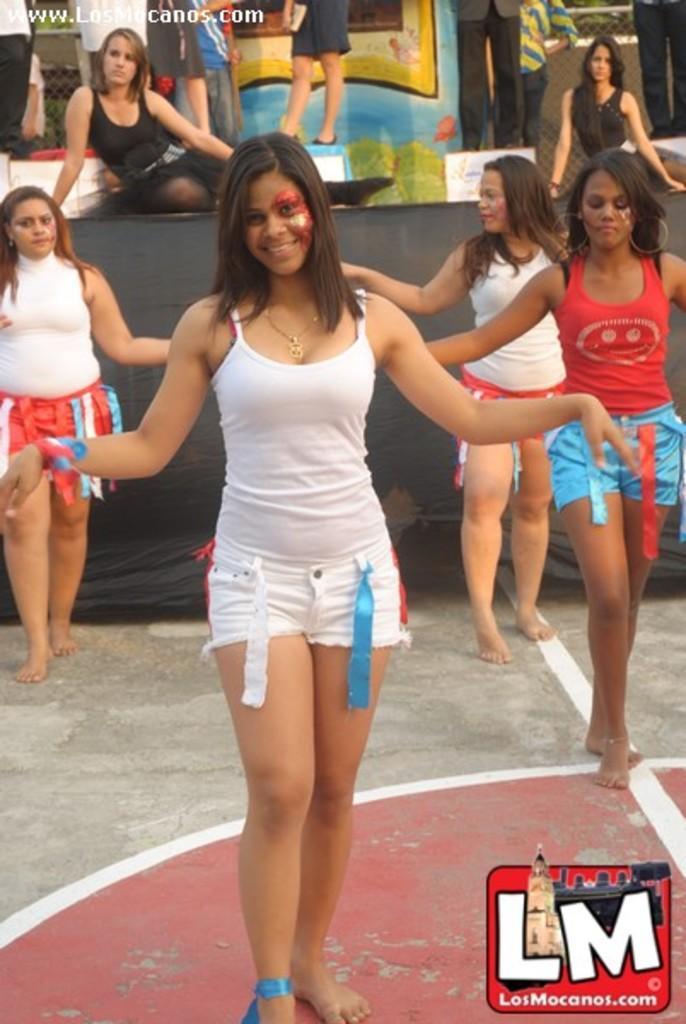How would you summarize this image in a sentence or two? In the picture I can see people among them some are sitting and some are standing on the floor. In the background I can see black color cloth and some other objects. I can also see watermarks on the image. 